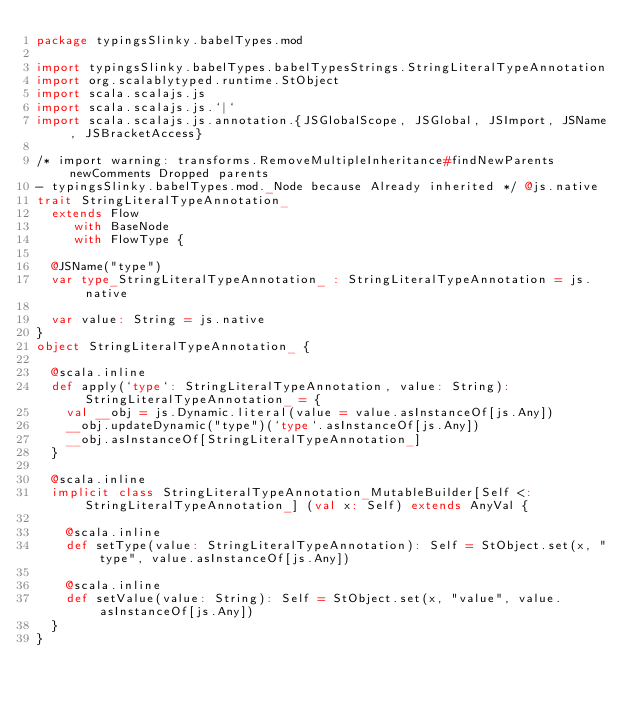<code> <loc_0><loc_0><loc_500><loc_500><_Scala_>package typingsSlinky.babelTypes.mod

import typingsSlinky.babelTypes.babelTypesStrings.StringLiteralTypeAnnotation
import org.scalablytyped.runtime.StObject
import scala.scalajs.js
import scala.scalajs.js.`|`
import scala.scalajs.js.annotation.{JSGlobalScope, JSGlobal, JSImport, JSName, JSBracketAccess}

/* import warning: transforms.RemoveMultipleInheritance#findNewParents newComments Dropped parents 
- typingsSlinky.babelTypes.mod._Node because Already inherited */ @js.native
trait StringLiteralTypeAnnotation_
  extends Flow
     with BaseNode
     with FlowType {
  
  @JSName("type")
  var type_StringLiteralTypeAnnotation_ : StringLiteralTypeAnnotation = js.native
  
  var value: String = js.native
}
object StringLiteralTypeAnnotation_ {
  
  @scala.inline
  def apply(`type`: StringLiteralTypeAnnotation, value: String): StringLiteralTypeAnnotation_ = {
    val __obj = js.Dynamic.literal(value = value.asInstanceOf[js.Any])
    __obj.updateDynamic("type")(`type`.asInstanceOf[js.Any])
    __obj.asInstanceOf[StringLiteralTypeAnnotation_]
  }
  
  @scala.inline
  implicit class StringLiteralTypeAnnotation_MutableBuilder[Self <: StringLiteralTypeAnnotation_] (val x: Self) extends AnyVal {
    
    @scala.inline
    def setType(value: StringLiteralTypeAnnotation): Self = StObject.set(x, "type", value.asInstanceOf[js.Any])
    
    @scala.inline
    def setValue(value: String): Self = StObject.set(x, "value", value.asInstanceOf[js.Any])
  }
}
</code> 